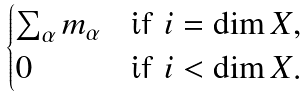Convert formula to latex. <formula><loc_0><loc_0><loc_500><loc_500>\begin{cases} \sum _ { \alpha } m _ { \alpha } & \text {if $i=\dim X$} , \\ 0 & \text {if $i<\dim X$} . \end{cases}</formula> 